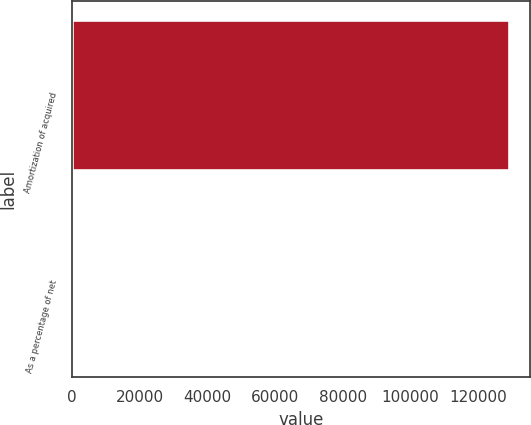Convert chart. <chart><loc_0><loc_0><loc_500><loc_500><bar_chart><fcel>Amortization of acquired<fcel>As a percentage of net<nl><fcel>128941<fcel>2.8<nl></chart> 